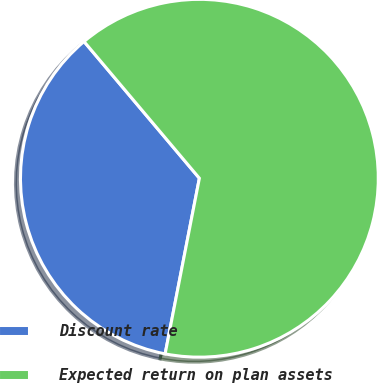Convert chart to OTSL. <chart><loc_0><loc_0><loc_500><loc_500><pie_chart><fcel>Discount rate<fcel>Expected return on plan assets<nl><fcel>35.78%<fcel>64.22%<nl></chart> 